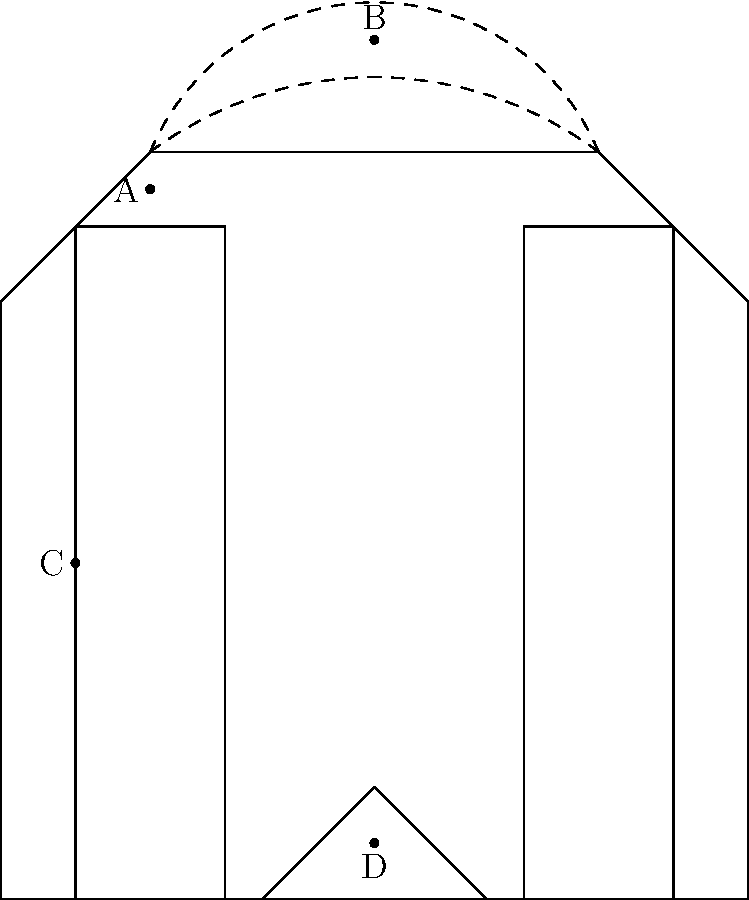In the diagram of the Tower Bridge, which labeled component (A, B, C, or D) represents the bascule mechanism that allows the bridge to open for tall ships passing through? To answer this question, let's analyze each labeled component in the diagram:

1. Component A: This point is located at the top of one of the towers. It represents the upper part of the bridge's iconic twin towers.

2. Component B: This point is at the peak of the curved line connecting the two towers. It represents the suspension cables that help support the bridge's walkways.

3. Component C: This point is located halfway up one of the vertical structures. It represents the main tower structure of the bridge.

4. Component D: This point is located at the center of the lower part of the bridge, where two angled lines meet. This represents the bascule mechanism.

The bascule mechanism is a counterweighted lever system that allows the bridge to open by lifting two sections of the roadway. This enables tall ships to pass through the bridge.

In the diagram, the two angled lines meeting at point D represent the two halves of the bascule bridge when it's closed. When the bridge opens, these sections would pivot upwards around points near the base of the towers.

Therefore, the component that represents the bascule mechanism is D.
Answer: D 